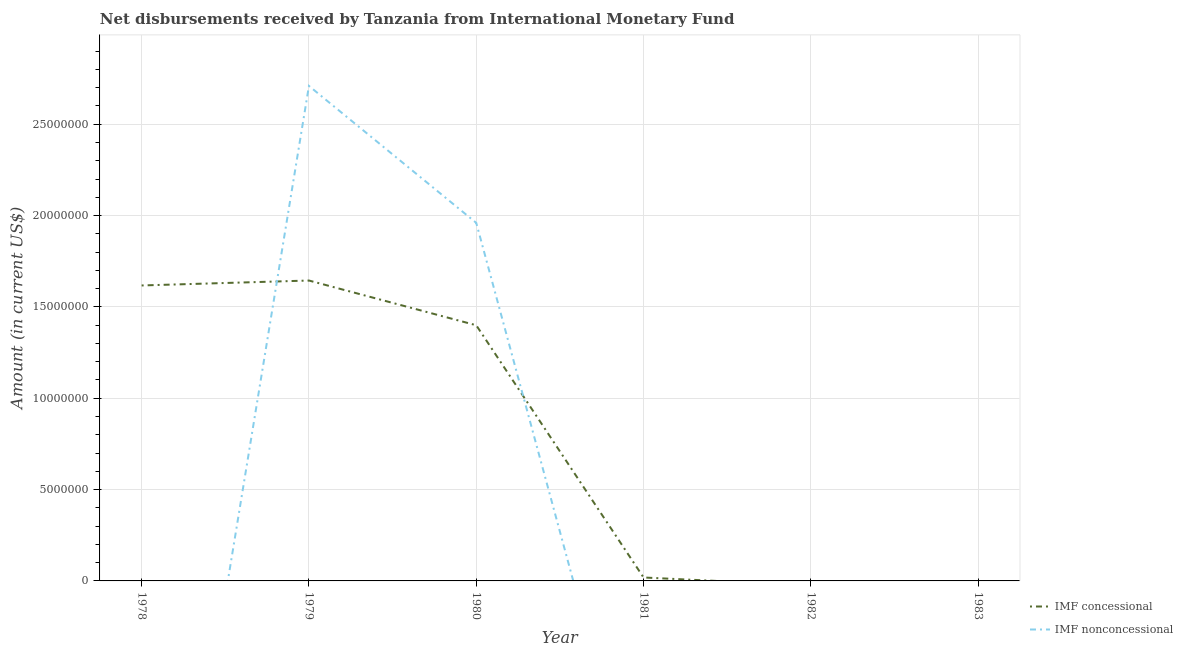Does the line corresponding to net non concessional disbursements from imf intersect with the line corresponding to net concessional disbursements from imf?
Ensure brevity in your answer.  Yes. Across all years, what is the maximum net non concessional disbursements from imf?
Your answer should be very brief. 2.71e+07. Across all years, what is the minimum net concessional disbursements from imf?
Make the answer very short. 0. In which year was the net non concessional disbursements from imf maximum?
Your response must be concise. 1979. What is the total net concessional disbursements from imf in the graph?
Offer a terse response. 4.68e+07. What is the difference between the net concessional disbursements from imf in 1980 and that in 1981?
Your response must be concise. 1.38e+07. What is the difference between the net concessional disbursements from imf in 1979 and the net non concessional disbursements from imf in 1982?
Keep it short and to the point. 1.64e+07. What is the average net non concessional disbursements from imf per year?
Offer a terse response. 7.78e+06. In the year 1979, what is the difference between the net non concessional disbursements from imf and net concessional disbursements from imf?
Provide a succinct answer. 1.07e+07. In how many years, is the net concessional disbursements from imf greater than 26000000 US$?
Your answer should be compact. 0. What is the ratio of the net non concessional disbursements from imf in 1979 to that in 1980?
Offer a terse response. 1.38. Is the net concessional disbursements from imf in 1980 less than that in 1981?
Provide a short and direct response. No. What is the difference between the highest and the lowest net concessional disbursements from imf?
Your answer should be compact. 1.64e+07. In how many years, is the net non concessional disbursements from imf greater than the average net non concessional disbursements from imf taken over all years?
Provide a short and direct response. 2. Does the net concessional disbursements from imf monotonically increase over the years?
Provide a succinct answer. No. Is the net non concessional disbursements from imf strictly greater than the net concessional disbursements from imf over the years?
Offer a very short reply. No. How many lines are there?
Your answer should be very brief. 2. Are the values on the major ticks of Y-axis written in scientific E-notation?
Ensure brevity in your answer.  No. Where does the legend appear in the graph?
Your answer should be very brief. Bottom right. What is the title of the graph?
Ensure brevity in your answer.  Net disbursements received by Tanzania from International Monetary Fund. Does "State government" appear as one of the legend labels in the graph?
Offer a very short reply. No. What is the label or title of the X-axis?
Keep it short and to the point. Year. What is the Amount (in current US$) in IMF concessional in 1978?
Ensure brevity in your answer.  1.62e+07. What is the Amount (in current US$) of IMF concessional in 1979?
Keep it short and to the point. 1.64e+07. What is the Amount (in current US$) of IMF nonconcessional in 1979?
Ensure brevity in your answer.  2.71e+07. What is the Amount (in current US$) of IMF concessional in 1980?
Ensure brevity in your answer.  1.40e+07. What is the Amount (in current US$) of IMF nonconcessional in 1980?
Ensure brevity in your answer.  1.96e+07. What is the Amount (in current US$) of IMF concessional in 1981?
Offer a very short reply. 1.88e+05. What is the Amount (in current US$) in IMF nonconcessional in 1981?
Keep it short and to the point. 0. What is the Amount (in current US$) in IMF concessional in 1982?
Keep it short and to the point. 0. What is the Amount (in current US$) in IMF nonconcessional in 1982?
Provide a succinct answer. 0. What is the Amount (in current US$) of IMF concessional in 1983?
Offer a terse response. 0. Across all years, what is the maximum Amount (in current US$) in IMF concessional?
Your answer should be very brief. 1.64e+07. Across all years, what is the maximum Amount (in current US$) in IMF nonconcessional?
Keep it short and to the point. 2.71e+07. Across all years, what is the minimum Amount (in current US$) in IMF nonconcessional?
Provide a short and direct response. 0. What is the total Amount (in current US$) of IMF concessional in the graph?
Ensure brevity in your answer.  4.68e+07. What is the total Amount (in current US$) of IMF nonconcessional in the graph?
Your answer should be compact. 4.67e+07. What is the difference between the Amount (in current US$) of IMF concessional in 1978 and that in 1979?
Your answer should be very brief. -2.70e+05. What is the difference between the Amount (in current US$) in IMF concessional in 1978 and that in 1980?
Provide a succinct answer. 2.18e+06. What is the difference between the Amount (in current US$) of IMF concessional in 1978 and that in 1981?
Offer a very short reply. 1.60e+07. What is the difference between the Amount (in current US$) in IMF concessional in 1979 and that in 1980?
Keep it short and to the point. 2.45e+06. What is the difference between the Amount (in current US$) in IMF nonconcessional in 1979 and that in 1980?
Provide a short and direct response. 7.50e+06. What is the difference between the Amount (in current US$) in IMF concessional in 1979 and that in 1981?
Your response must be concise. 1.63e+07. What is the difference between the Amount (in current US$) of IMF concessional in 1980 and that in 1981?
Offer a very short reply. 1.38e+07. What is the difference between the Amount (in current US$) in IMF concessional in 1978 and the Amount (in current US$) in IMF nonconcessional in 1979?
Your answer should be compact. -1.09e+07. What is the difference between the Amount (in current US$) in IMF concessional in 1978 and the Amount (in current US$) in IMF nonconcessional in 1980?
Give a very brief answer. -3.43e+06. What is the difference between the Amount (in current US$) in IMF concessional in 1979 and the Amount (in current US$) in IMF nonconcessional in 1980?
Offer a terse response. -3.16e+06. What is the average Amount (in current US$) of IMF concessional per year?
Offer a very short reply. 7.80e+06. What is the average Amount (in current US$) of IMF nonconcessional per year?
Make the answer very short. 7.78e+06. In the year 1979, what is the difference between the Amount (in current US$) in IMF concessional and Amount (in current US$) in IMF nonconcessional?
Your answer should be very brief. -1.07e+07. In the year 1980, what is the difference between the Amount (in current US$) in IMF concessional and Amount (in current US$) in IMF nonconcessional?
Make the answer very short. -5.60e+06. What is the ratio of the Amount (in current US$) of IMF concessional in 1978 to that in 1979?
Provide a short and direct response. 0.98. What is the ratio of the Amount (in current US$) of IMF concessional in 1978 to that in 1980?
Your answer should be compact. 1.16. What is the ratio of the Amount (in current US$) in IMF concessional in 1978 to that in 1981?
Ensure brevity in your answer.  86.03. What is the ratio of the Amount (in current US$) of IMF concessional in 1979 to that in 1980?
Offer a terse response. 1.17. What is the ratio of the Amount (in current US$) of IMF nonconcessional in 1979 to that in 1980?
Offer a terse response. 1.38. What is the ratio of the Amount (in current US$) of IMF concessional in 1979 to that in 1981?
Offer a terse response. 87.46. What is the ratio of the Amount (in current US$) of IMF concessional in 1980 to that in 1981?
Ensure brevity in your answer.  74.44. What is the difference between the highest and the lowest Amount (in current US$) in IMF concessional?
Make the answer very short. 1.64e+07. What is the difference between the highest and the lowest Amount (in current US$) in IMF nonconcessional?
Ensure brevity in your answer.  2.71e+07. 